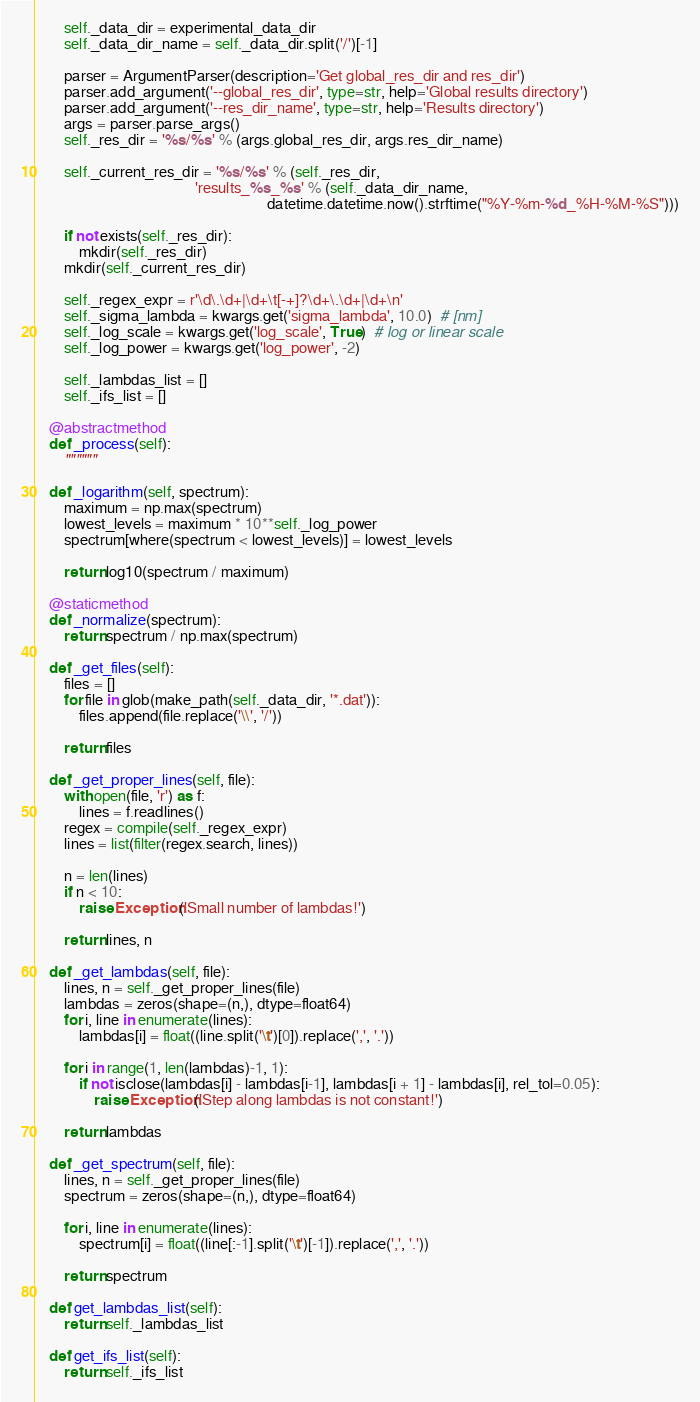<code> <loc_0><loc_0><loc_500><loc_500><_Python_>
        self._data_dir = experimental_data_dir
        self._data_dir_name = self._data_dir.split('/')[-1]

        parser = ArgumentParser(description='Get global_res_dir and res_dir')
        parser.add_argument('--global_res_dir', type=str, help='Global results directory')
        parser.add_argument('--res_dir_name', type=str, help='Results directory')
        args = parser.parse_args()
        self._res_dir = '%s/%s' % (args.global_res_dir, args.res_dir_name)

        self._current_res_dir = '%s/%s' % (self._res_dir,
                                           'results_%s_%s' % (self._data_dir_name,
                                                              datetime.datetime.now().strftime("%Y-%m-%d_%H-%M-%S")))

        if not exists(self._res_dir):
            mkdir(self._res_dir)
        mkdir(self._current_res_dir)

        self._regex_expr = r'\d\.\d+|\d+\t[-+]?\d+\.\d+|\d+\n'
        self._sigma_lambda = kwargs.get('sigma_lambda', 10.0)  # [nm]
        self._log_scale = kwargs.get('log_scale', True)  # log or linear scale
        self._log_power = kwargs.get('log_power', -2)

        self._lambdas_list = []
        self._ifs_list = []

    @abstractmethod
    def _process(self):
        """"""

    def _logarithm(self, spectrum):
        maximum = np.max(spectrum)
        lowest_levels = maximum * 10**self._log_power
        spectrum[where(spectrum < lowest_levels)] = lowest_levels

        return log10(spectrum / maximum)

    @staticmethod
    def _normalize(spectrum):
        return spectrum / np.max(spectrum)

    def _get_files(self):
        files = []
        for file in glob(make_path(self._data_dir, '*.dat')):
            files.append(file.replace('\\', '/'))

        return files

    def _get_proper_lines(self, file):
        with open(file, 'r') as f:
            lines = f.readlines()
        regex = compile(self._regex_expr)
        lines = list(filter(regex.search, lines))

        n = len(lines)
        if n < 10:
            raise Exception('Small number of lambdas!')

        return lines, n

    def _get_lambdas(self, file):
        lines, n = self._get_proper_lines(file)
        lambdas = zeros(shape=(n,), dtype=float64)
        for i, line in enumerate(lines):
            lambdas[i] = float((line.split('\t')[0]).replace(',', '.'))

        for i in range(1, len(lambdas)-1, 1):
            if not isclose(lambdas[i] - lambdas[i-1], lambdas[i + 1] - lambdas[i], rel_tol=0.05):
                raise Exception('Step along lambdas is not constant!')

        return lambdas

    def _get_spectrum(self, file):
        lines, n = self._get_proper_lines(file)
        spectrum = zeros(shape=(n,), dtype=float64)

        for i, line in enumerate(lines):
            spectrum[i] = float((line[:-1].split('\t')[-1]).replace(',', '.'))

        return spectrum

    def get_lambdas_list(self):
        return self._lambdas_list

    def get_ifs_list(self):
        return self._ifs_list
</code> 